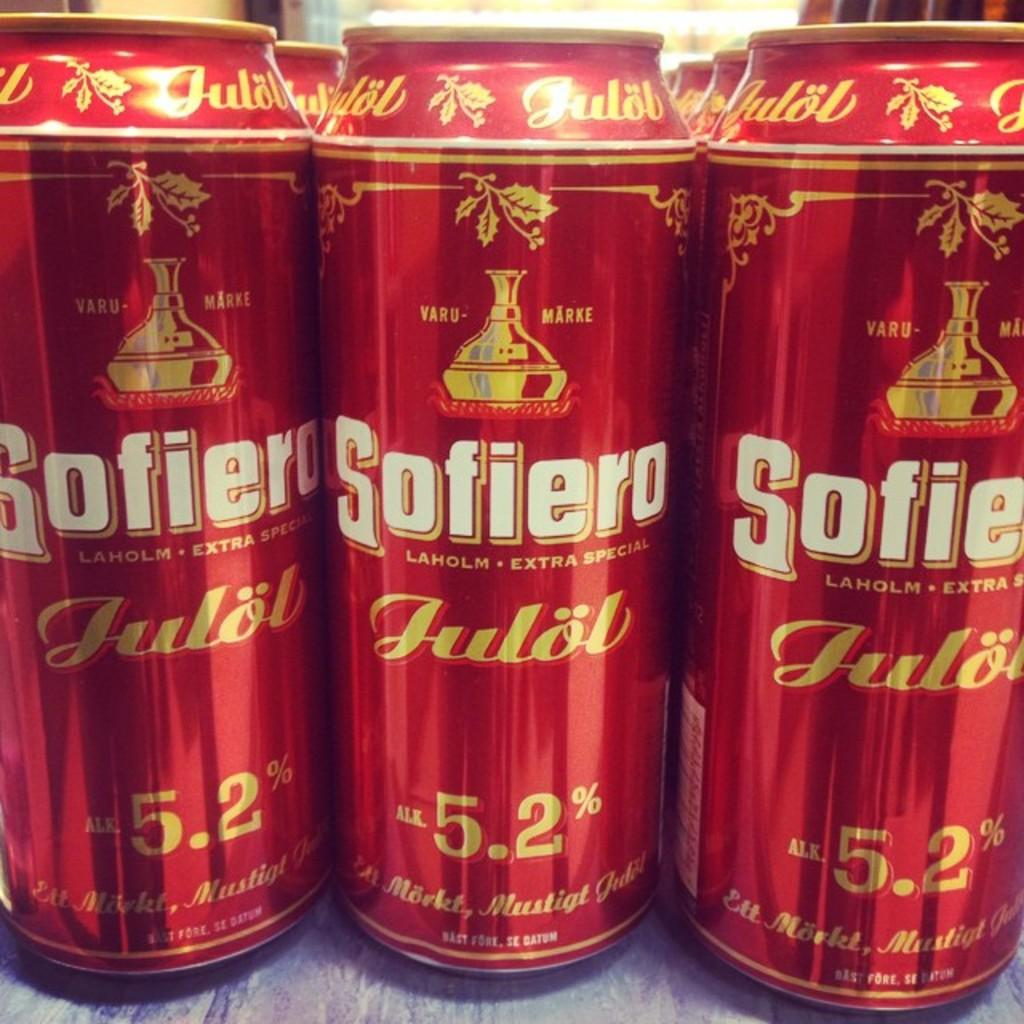<image>
Summarize the visual content of the image. A row of beer cans that say Sofiero Laholm Extra Special. 